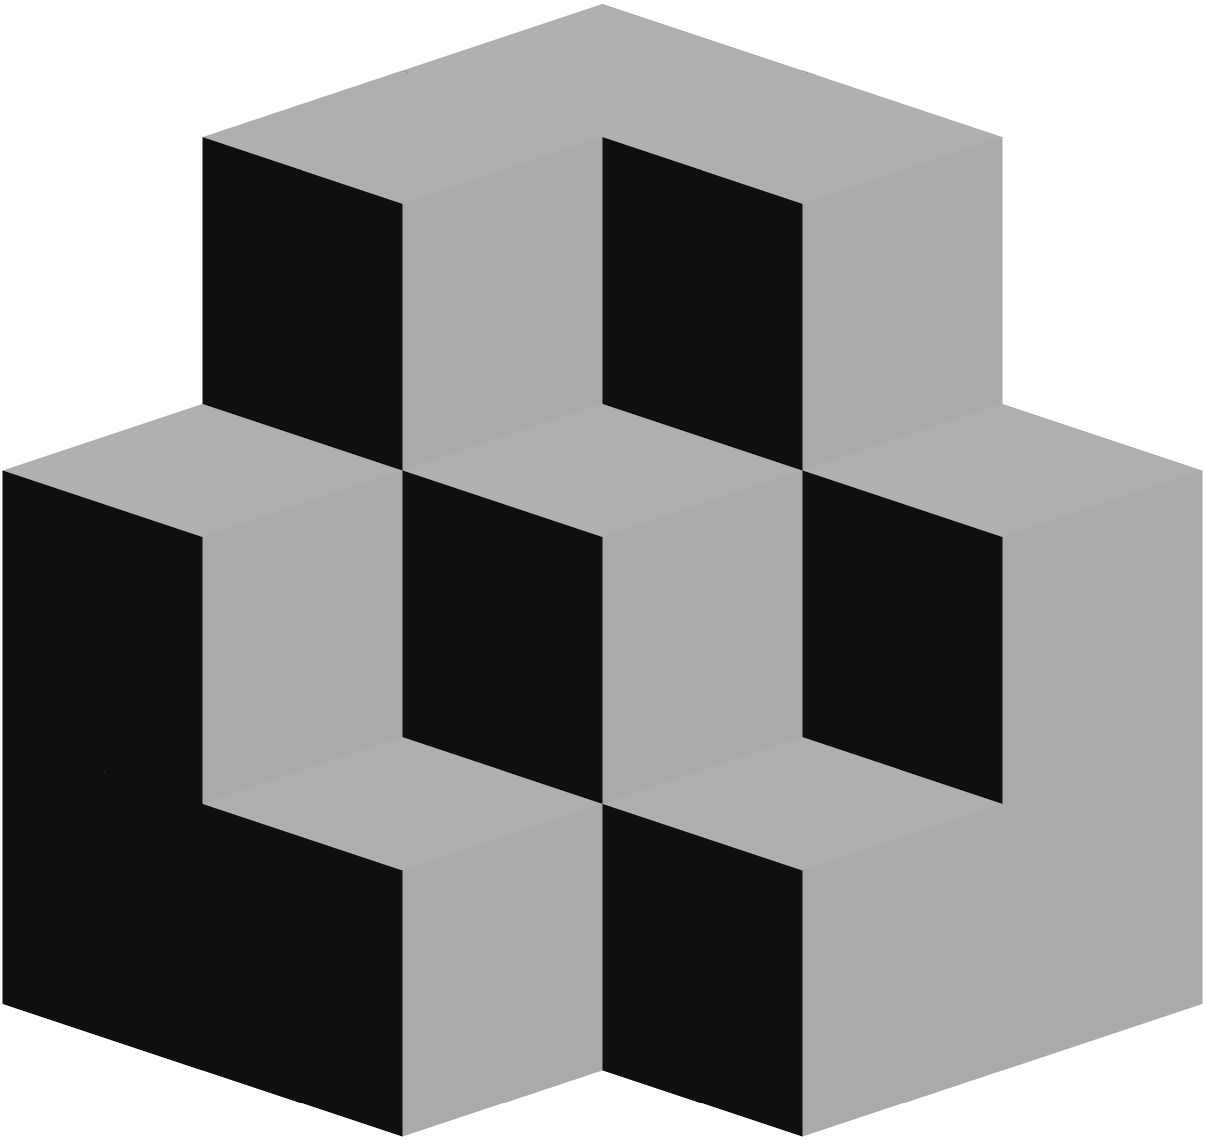In this diagram, you see a stack of cubes arranged in a peculiar formation. Some cubes may be hidden from view. Based on the visible arrangement, how many cubes in total are present in this stack? Let's approach this step-by-step:

1. First, we need to understand the structure. It appears to be a 3x3x3 grid, but not all spaces are filled.

2. Let's count the visible cubes layer by layer:
   - Bottom layer: We can see 5 cubes clearly.
   - Middle layer: We can see 3 cubes.
   - Top layer: We can see 1 cube at the very top.

3. However, we need to consider that some cubes might be hidden from view.

4. Given the structure, we can deduce that there must be a cube in the center of the bottom layer, which we can't see. This brings the total for the bottom layer to 6.

5. The middle layer likely has a cube behind the visible ones, making it 4 in total.

6. The top layer is just the one visible cube.

7. Therefore, the total count is:
   Bottom layer: 6
   Middle layer: 4
   Top layer: 1

8. Adding these up: 6 + 4 + 1 = 11

So, there are 11 cubes in total in this stack.
Answer: 11 cubes 